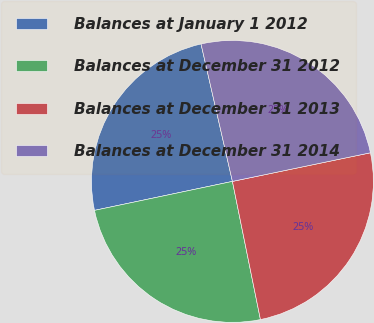Convert chart to OTSL. <chart><loc_0><loc_0><loc_500><loc_500><pie_chart><fcel>Balances at January 1 2012<fcel>Balances at December 31 2012<fcel>Balances at December 31 2013<fcel>Balances at December 31 2014<nl><fcel>24.72%<fcel>24.89%<fcel>25.07%<fcel>25.32%<nl></chart> 